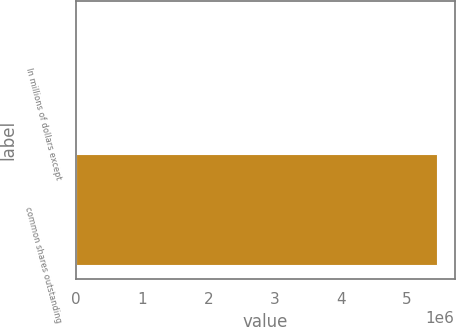Convert chart to OTSL. <chart><loc_0><loc_0><loc_500><loc_500><bar_chart><fcel>In millions of dollars except<fcel>common shares outstanding<nl><fcel>2008<fcel>5.45007e+06<nl></chart> 